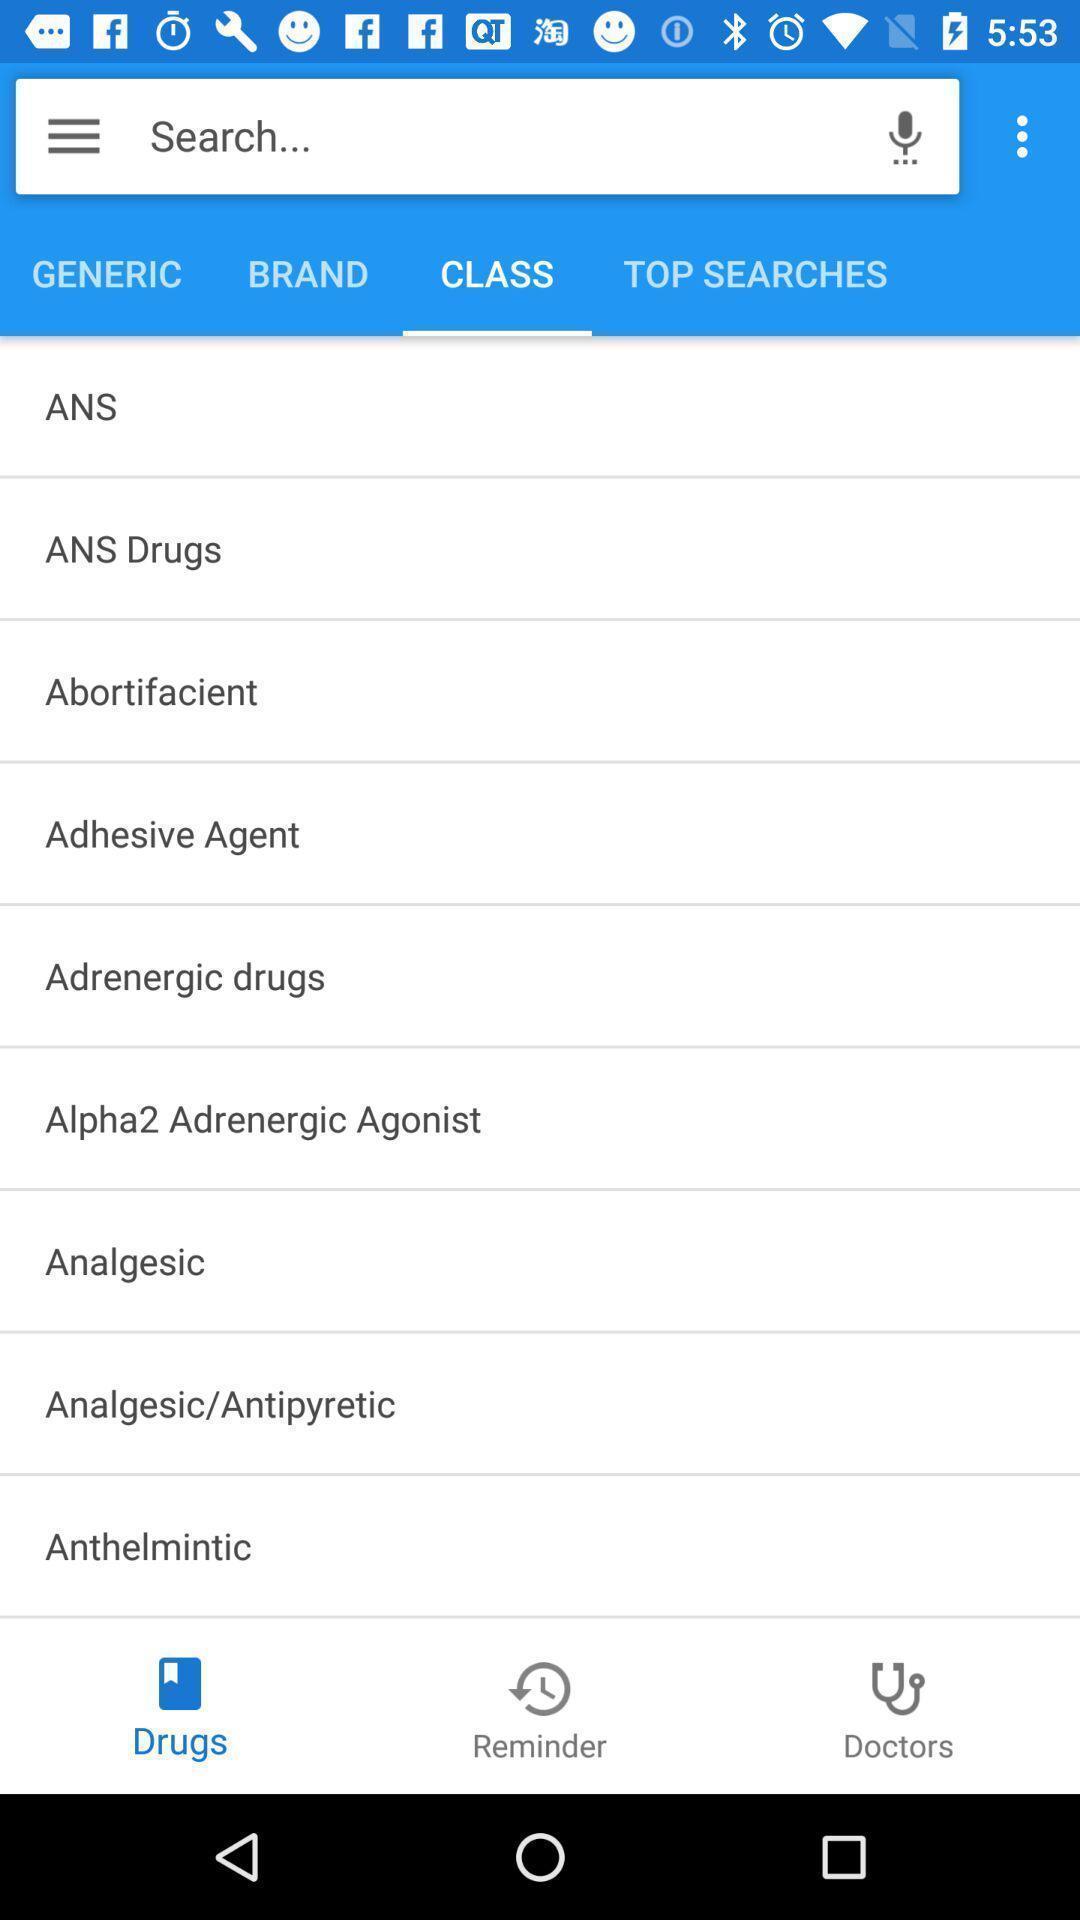Describe the key features of this screenshot. Page displaying various information in medical application. 